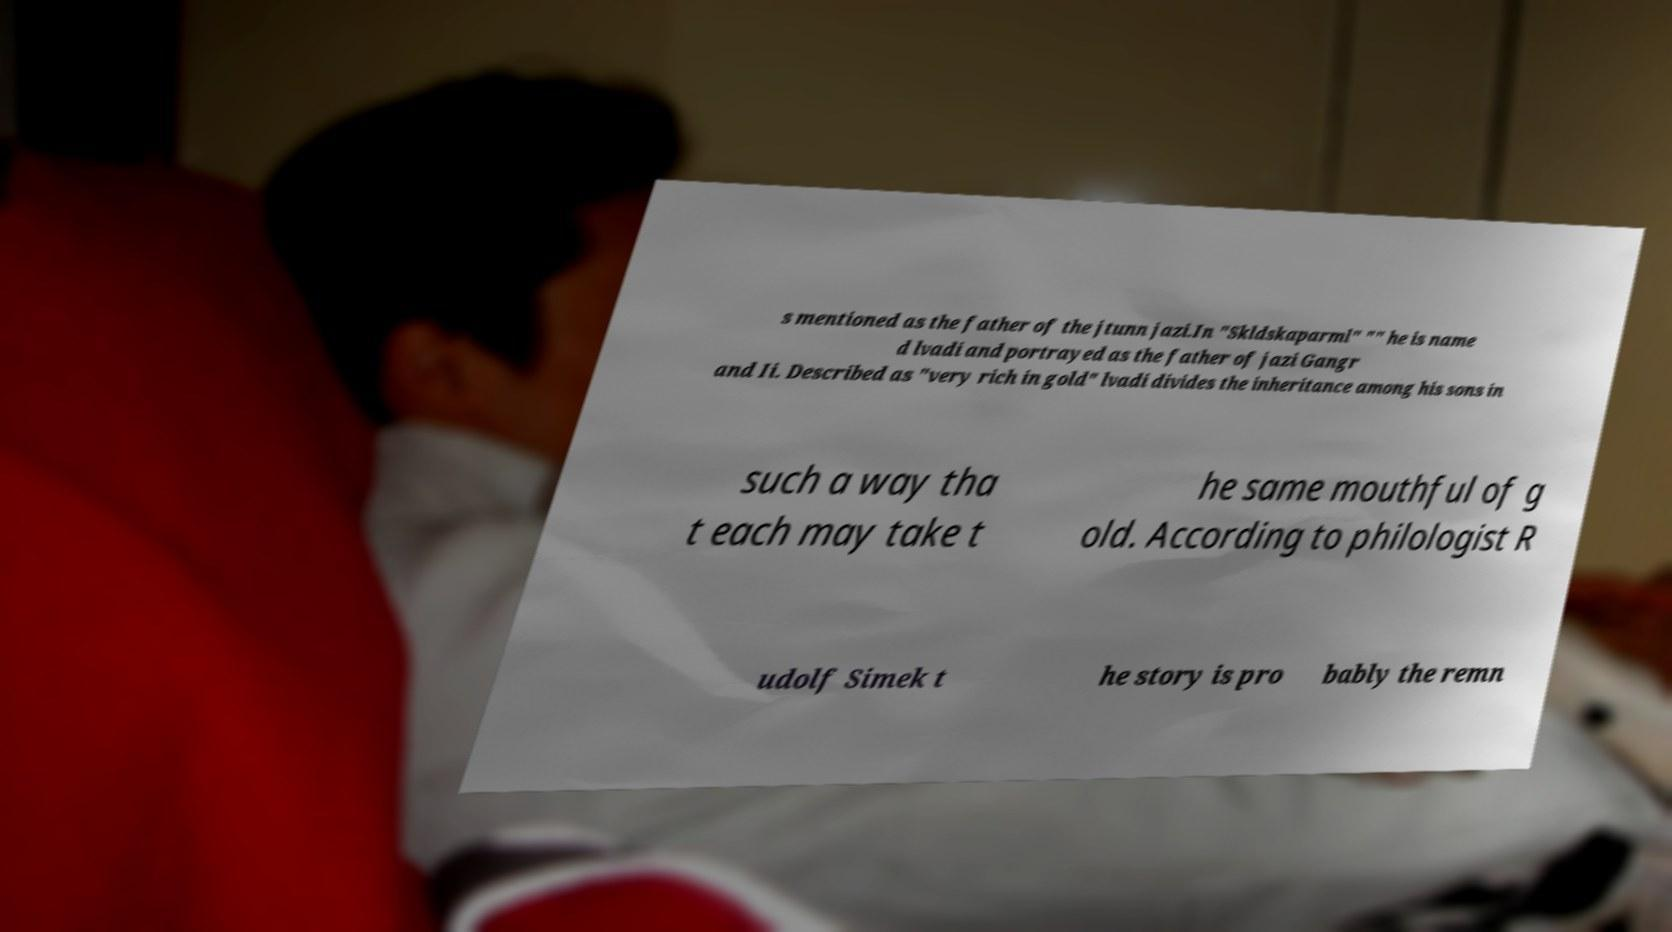What messages or text are displayed in this image? I need them in a readable, typed format. s mentioned as the father of the jtunn jazi.In "Skldskaparml" "" he is name d lvadi and portrayed as the father of jazi Gangr and Ii. Described as "very rich in gold" lvadi divides the inheritance among his sons in such a way tha t each may take t he same mouthful of g old. According to philologist R udolf Simek t he story is pro bably the remn 